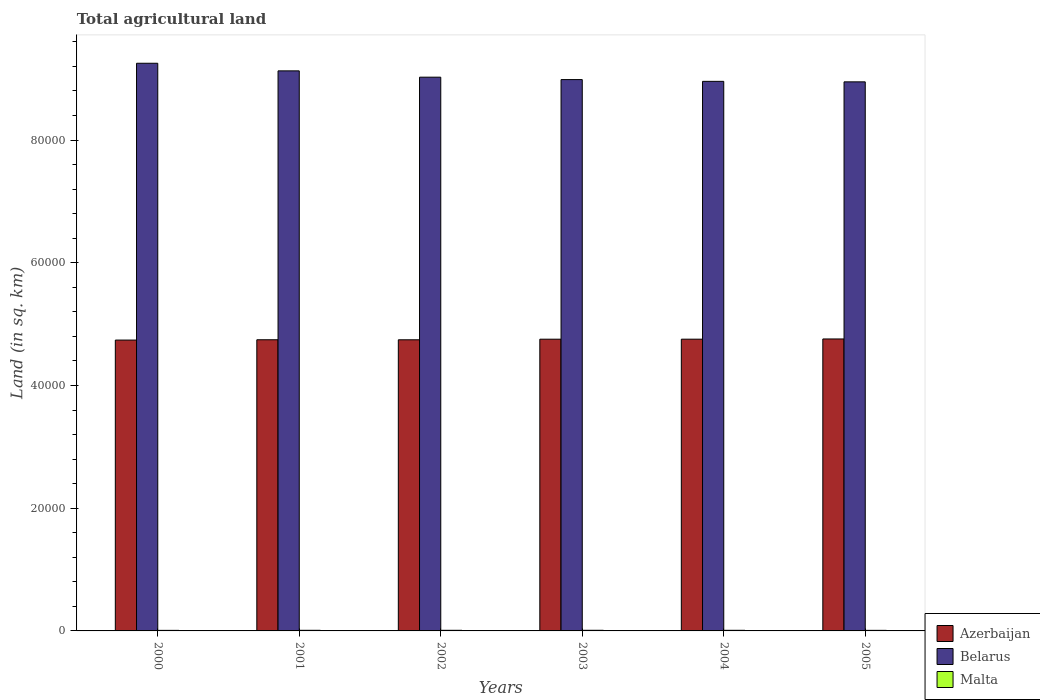Are the number of bars per tick equal to the number of legend labels?
Keep it short and to the point. Yes. Are the number of bars on each tick of the X-axis equal?
Your response must be concise. Yes. What is the total agricultural land in Malta in 2003?
Your response must be concise. 104. Across all years, what is the maximum total agricultural land in Belarus?
Offer a very short reply. 9.25e+04. Across all years, what is the minimum total agricultural land in Azerbaijan?
Provide a succinct answer. 4.74e+04. In which year was the total agricultural land in Malta maximum?
Provide a succinct answer. 2003. In which year was the total agricultural land in Belarus minimum?
Offer a terse response. 2005. What is the total total agricultural land in Malta in the graph?
Provide a succinct answer. 587. What is the difference between the total agricultural land in Azerbaijan in 2000 and the total agricultural land in Belarus in 2001?
Provide a succinct answer. -4.39e+04. What is the average total agricultural land in Belarus per year?
Provide a short and direct response. 9.05e+04. In the year 2001, what is the difference between the total agricultural land in Malta and total agricultural land in Belarus?
Offer a very short reply. -9.12e+04. In how many years, is the total agricultural land in Malta greater than 32000 sq.km?
Your answer should be very brief. 0. What is the ratio of the total agricultural land in Azerbaijan in 2001 to that in 2002?
Your answer should be compact. 1. Is the total agricultural land in Belarus in 2000 less than that in 2002?
Ensure brevity in your answer.  No. Is the difference between the total agricultural land in Malta in 2000 and 2005 greater than the difference between the total agricultural land in Belarus in 2000 and 2005?
Ensure brevity in your answer.  No. What is the difference between the highest and the second highest total agricultural land in Azerbaijan?
Make the answer very short. 37. In how many years, is the total agricultural land in Belarus greater than the average total agricultural land in Belarus taken over all years?
Ensure brevity in your answer.  2. What does the 3rd bar from the left in 2002 represents?
Make the answer very short. Malta. What does the 2nd bar from the right in 2003 represents?
Your answer should be very brief. Belarus. Is it the case that in every year, the sum of the total agricultural land in Malta and total agricultural land in Azerbaijan is greater than the total agricultural land in Belarus?
Provide a succinct answer. No. Are all the bars in the graph horizontal?
Offer a terse response. No. How many years are there in the graph?
Give a very brief answer. 6. What is the difference between two consecutive major ticks on the Y-axis?
Your answer should be compact. 2.00e+04. Are the values on the major ticks of Y-axis written in scientific E-notation?
Your answer should be compact. No. Does the graph contain any zero values?
Provide a short and direct response. No. Does the graph contain grids?
Make the answer very short. No. How many legend labels are there?
Keep it short and to the point. 3. What is the title of the graph?
Offer a terse response. Total agricultural land. What is the label or title of the X-axis?
Provide a succinct answer. Years. What is the label or title of the Y-axis?
Keep it short and to the point. Land (in sq. km). What is the Land (in sq. km) of Azerbaijan in 2000?
Provide a short and direct response. 4.74e+04. What is the Land (in sq. km) in Belarus in 2000?
Provide a succinct answer. 9.25e+04. What is the Land (in sq. km) in Malta in 2000?
Keep it short and to the point. 90. What is the Land (in sq. km) of Azerbaijan in 2001?
Your response must be concise. 4.75e+04. What is the Land (in sq. km) in Belarus in 2001?
Provide a succinct answer. 9.13e+04. What is the Land (in sq. km) in Malta in 2001?
Give a very brief answer. 100. What is the Land (in sq. km) of Azerbaijan in 2002?
Keep it short and to the point. 4.74e+04. What is the Land (in sq. km) of Belarus in 2002?
Offer a terse response. 9.02e+04. What is the Land (in sq. km) of Azerbaijan in 2003?
Make the answer very short. 4.75e+04. What is the Land (in sq. km) in Belarus in 2003?
Your answer should be very brief. 8.99e+04. What is the Land (in sq. km) of Malta in 2003?
Your response must be concise. 104. What is the Land (in sq. km) in Azerbaijan in 2004?
Make the answer very short. 4.75e+04. What is the Land (in sq. km) in Belarus in 2004?
Give a very brief answer. 8.96e+04. What is the Land (in sq. km) of Malta in 2004?
Your answer should be compact. 100. What is the Land (in sq. km) in Azerbaijan in 2005?
Keep it short and to the point. 4.76e+04. What is the Land (in sq. km) in Belarus in 2005?
Provide a short and direct response. 8.95e+04. What is the Land (in sq. km) of Malta in 2005?
Give a very brief answer. 93. Across all years, what is the maximum Land (in sq. km) of Azerbaijan?
Provide a short and direct response. 4.76e+04. Across all years, what is the maximum Land (in sq. km) of Belarus?
Offer a very short reply. 9.25e+04. Across all years, what is the maximum Land (in sq. km) in Malta?
Give a very brief answer. 104. Across all years, what is the minimum Land (in sq. km) of Azerbaijan?
Offer a very short reply. 4.74e+04. Across all years, what is the minimum Land (in sq. km) in Belarus?
Ensure brevity in your answer.  8.95e+04. Across all years, what is the minimum Land (in sq. km) in Malta?
Offer a terse response. 90. What is the total Land (in sq. km) of Azerbaijan in the graph?
Your answer should be very brief. 2.85e+05. What is the total Land (in sq. km) in Belarus in the graph?
Your answer should be compact. 5.43e+05. What is the total Land (in sq. km) of Malta in the graph?
Your answer should be compact. 587. What is the difference between the Land (in sq. km) in Azerbaijan in 2000 and that in 2001?
Your answer should be compact. -52. What is the difference between the Land (in sq. km) in Belarus in 2000 and that in 2001?
Provide a succinct answer. 1240. What is the difference between the Land (in sq. km) in Azerbaijan in 2000 and that in 2002?
Give a very brief answer. -45. What is the difference between the Land (in sq. km) of Belarus in 2000 and that in 2002?
Give a very brief answer. 2270. What is the difference between the Land (in sq. km) of Azerbaijan in 2000 and that in 2003?
Give a very brief answer. -142. What is the difference between the Land (in sq. km) of Belarus in 2000 and that in 2003?
Offer a very short reply. 2660. What is the difference between the Land (in sq. km) of Azerbaijan in 2000 and that in 2004?
Give a very brief answer. -145. What is the difference between the Land (in sq. km) of Belarus in 2000 and that in 2004?
Keep it short and to the point. 2950. What is the difference between the Land (in sq. km) of Malta in 2000 and that in 2004?
Offer a terse response. -10. What is the difference between the Land (in sq. km) in Azerbaijan in 2000 and that in 2005?
Keep it short and to the point. -182. What is the difference between the Land (in sq. km) in Belarus in 2000 and that in 2005?
Offer a very short reply. 3030. What is the difference between the Land (in sq. km) of Azerbaijan in 2001 and that in 2002?
Make the answer very short. 7. What is the difference between the Land (in sq. km) in Belarus in 2001 and that in 2002?
Your answer should be very brief. 1030. What is the difference between the Land (in sq. km) of Azerbaijan in 2001 and that in 2003?
Give a very brief answer. -90. What is the difference between the Land (in sq. km) in Belarus in 2001 and that in 2003?
Make the answer very short. 1420. What is the difference between the Land (in sq. km) of Azerbaijan in 2001 and that in 2004?
Ensure brevity in your answer.  -93. What is the difference between the Land (in sq. km) of Belarus in 2001 and that in 2004?
Keep it short and to the point. 1710. What is the difference between the Land (in sq. km) of Azerbaijan in 2001 and that in 2005?
Offer a very short reply. -130. What is the difference between the Land (in sq. km) in Belarus in 2001 and that in 2005?
Offer a very short reply. 1790. What is the difference between the Land (in sq. km) in Malta in 2001 and that in 2005?
Your answer should be compact. 7. What is the difference between the Land (in sq. km) in Azerbaijan in 2002 and that in 2003?
Make the answer very short. -97. What is the difference between the Land (in sq. km) of Belarus in 2002 and that in 2003?
Your answer should be very brief. 390. What is the difference between the Land (in sq. km) in Malta in 2002 and that in 2003?
Ensure brevity in your answer.  -4. What is the difference between the Land (in sq. km) of Azerbaijan in 2002 and that in 2004?
Give a very brief answer. -100. What is the difference between the Land (in sq. km) of Belarus in 2002 and that in 2004?
Provide a short and direct response. 680. What is the difference between the Land (in sq. km) of Azerbaijan in 2002 and that in 2005?
Your answer should be compact. -137. What is the difference between the Land (in sq. km) of Belarus in 2002 and that in 2005?
Keep it short and to the point. 760. What is the difference between the Land (in sq. km) in Azerbaijan in 2003 and that in 2004?
Ensure brevity in your answer.  -3. What is the difference between the Land (in sq. km) of Belarus in 2003 and that in 2004?
Your response must be concise. 290. What is the difference between the Land (in sq. km) of Belarus in 2003 and that in 2005?
Offer a very short reply. 370. What is the difference between the Land (in sq. km) in Malta in 2003 and that in 2005?
Offer a terse response. 11. What is the difference between the Land (in sq. km) of Azerbaijan in 2004 and that in 2005?
Your answer should be compact. -37. What is the difference between the Land (in sq. km) of Azerbaijan in 2000 and the Land (in sq. km) of Belarus in 2001?
Make the answer very short. -4.39e+04. What is the difference between the Land (in sq. km) of Azerbaijan in 2000 and the Land (in sq. km) of Malta in 2001?
Ensure brevity in your answer.  4.73e+04. What is the difference between the Land (in sq. km) of Belarus in 2000 and the Land (in sq. km) of Malta in 2001?
Your response must be concise. 9.24e+04. What is the difference between the Land (in sq. km) in Azerbaijan in 2000 and the Land (in sq. km) in Belarus in 2002?
Offer a very short reply. -4.28e+04. What is the difference between the Land (in sq. km) of Azerbaijan in 2000 and the Land (in sq. km) of Malta in 2002?
Keep it short and to the point. 4.73e+04. What is the difference between the Land (in sq. km) in Belarus in 2000 and the Land (in sq. km) in Malta in 2002?
Offer a terse response. 9.24e+04. What is the difference between the Land (in sq. km) of Azerbaijan in 2000 and the Land (in sq. km) of Belarus in 2003?
Provide a short and direct response. -4.25e+04. What is the difference between the Land (in sq. km) of Azerbaijan in 2000 and the Land (in sq. km) of Malta in 2003?
Your answer should be compact. 4.73e+04. What is the difference between the Land (in sq. km) of Belarus in 2000 and the Land (in sq. km) of Malta in 2003?
Provide a short and direct response. 9.24e+04. What is the difference between the Land (in sq. km) in Azerbaijan in 2000 and the Land (in sq. km) in Belarus in 2004?
Offer a very short reply. -4.22e+04. What is the difference between the Land (in sq. km) of Azerbaijan in 2000 and the Land (in sq. km) of Malta in 2004?
Your answer should be very brief. 4.73e+04. What is the difference between the Land (in sq. km) of Belarus in 2000 and the Land (in sq. km) of Malta in 2004?
Provide a short and direct response. 9.24e+04. What is the difference between the Land (in sq. km) in Azerbaijan in 2000 and the Land (in sq. km) in Belarus in 2005?
Provide a succinct answer. -4.21e+04. What is the difference between the Land (in sq. km) of Azerbaijan in 2000 and the Land (in sq. km) of Malta in 2005?
Provide a short and direct response. 4.73e+04. What is the difference between the Land (in sq. km) of Belarus in 2000 and the Land (in sq. km) of Malta in 2005?
Make the answer very short. 9.24e+04. What is the difference between the Land (in sq. km) of Azerbaijan in 2001 and the Land (in sq. km) of Belarus in 2002?
Offer a terse response. -4.28e+04. What is the difference between the Land (in sq. km) of Azerbaijan in 2001 and the Land (in sq. km) of Malta in 2002?
Ensure brevity in your answer.  4.74e+04. What is the difference between the Land (in sq. km) in Belarus in 2001 and the Land (in sq. km) in Malta in 2002?
Your answer should be compact. 9.12e+04. What is the difference between the Land (in sq. km) of Azerbaijan in 2001 and the Land (in sq. km) of Belarus in 2003?
Provide a succinct answer. -4.24e+04. What is the difference between the Land (in sq. km) of Azerbaijan in 2001 and the Land (in sq. km) of Malta in 2003?
Provide a short and direct response. 4.74e+04. What is the difference between the Land (in sq. km) in Belarus in 2001 and the Land (in sq. km) in Malta in 2003?
Offer a terse response. 9.12e+04. What is the difference between the Land (in sq. km) in Azerbaijan in 2001 and the Land (in sq. km) in Belarus in 2004?
Your answer should be compact. -4.21e+04. What is the difference between the Land (in sq. km) in Azerbaijan in 2001 and the Land (in sq. km) in Malta in 2004?
Keep it short and to the point. 4.74e+04. What is the difference between the Land (in sq. km) in Belarus in 2001 and the Land (in sq. km) in Malta in 2004?
Offer a terse response. 9.12e+04. What is the difference between the Land (in sq. km) of Azerbaijan in 2001 and the Land (in sq. km) of Belarus in 2005?
Provide a succinct answer. -4.20e+04. What is the difference between the Land (in sq. km) in Azerbaijan in 2001 and the Land (in sq. km) in Malta in 2005?
Your answer should be compact. 4.74e+04. What is the difference between the Land (in sq. km) in Belarus in 2001 and the Land (in sq. km) in Malta in 2005?
Your answer should be compact. 9.12e+04. What is the difference between the Land (in sq. km) of Azerbaijan in 2002 and the Land (in sq. km) of Belarus in 2003?
Your response must be concise. -4.24e+04. What is the difference between the Land (in sq. km) in Azerbaijan in 2002 and the Land (in sq. km) in Malta in 2003?
Keep it short and to the point. 4.73e+04. What is the difference between the Land (in sq. km) of Belarus in 2002 and the Land (in sq. km) of Malta in 2003?
Provide a short and direct response. 9.01e+04. What is the difference between the Land (in sq. km) in Azerbaijan in 2002 and the Land (in sq. km) in Belarus in 2004?
Give a very brief answer. -4.21e+04. What is the difference between the Land (in sq. km) in Azerbaijan in 2002 and the Land (in sq. km) in Malta in 2004?
Your answer should be compact. 4.73e+04. What is the difference between the Land (in sq. km) in Belarus in 2002 and the Land (in sq. km) in Malta in 2004?
Give a very brief answer. 9.02e+04. What is the difference between the Land (in sq. km) of Azerbaijan in 2002 and the Land (in sq. km) of Belarus in 2005?
Ensure brevity in your answer.  -4.20e+04. What is the difference between the Land (in sq. km) in Azerbaijan in 2002 and the Land (in sq. km) in Malta in 2005?
Offer a terse response. 4.74e+04. What is the difference between the Land (in sq. km) of Belarus in 2002 and the Land (in sq. km) of Malta in 2005?
Provide a short and direct response. 9.02e+04. What is the difference between the Land (in sq. km) of Azerbaijan in 2003 and the Land (in sq. km) of Belarus in 2004?
Provide a short and direct response. -4.20e+04. What is the difference between the Land (in sq. km) of Azerbaijan in 2003 and the Land (in sq. km) of Malta in 2004?
Provide a succinct answer. 4.74e+04. What is the difference between the Land (in sq. km) in Belarus in 2003 and the Land (in sq. km) in Malta in 2004?
Your answer should be very brief. 8.98e+04. What is the difference between the Land (in sq. km) in Azerbaijan in 2003 and the Land (in sq. km) in Belarus in 2005?
Keep it short and to the point. -4.19e+04. What is the difference between the Land (in sq. km) of Azerbaijan in 2003 and the Land (in sq. km) of Malta in 2005?
Your answer should be very brief. 4.75e+04. What is the difference between the Land (in sq. km) of Belarus in 2003 and the Land (in sq. km) of Malta in 2005?
Offer a terse response. 8.98e+04. What is the difference between the Land (in sq. km) in Azerbaijan in 2004 and the Land (in sq. km) in Belarus in 2005?
Offer a terse response. -4.19e+04. What is the difference between the Land (in sq. km) in Azerbaijan in 2004 and the Land (in sq. km) in Malta in 2005?
Offer a very short reply. 4.75e+04. What is the difference between the Land (in sq. km) in Belarus in 2004 and the Land (in sq. km) in Malta in 2005?
Provide a short and direct response. 8.95e+04. What is the average Land (in sq. km) of Azerbaijan per year?
Your answer should be compact. 4.75e+04. What is the average Land (in sq. km) in Belarus per year?
Your answer should be compact. 9.05e+04. What is the average Land (in sq. km) in Malta per year?
Give a very brief answer. 97.83. In the year 2000, what is the difference between the Land (in sq. km) of Azerbaijan and Land (in sq. km) of Belarus?
Give a very brief answer. -4.51e+04. In the year 2000, what is the difference between the Land (in sq. km) in Azerbaijan and Land (in sq. km) in Malta?
Keep it short and to the point. 4.73e+04. In the year 2000, what is the difference between the Land (in sq. km) in Belarus and Land (in sq. km) in Malta?
Your answer should be compact. 9.24e+04. In the year 2001, what is the difference between the Land (in sq. km) of Azerbaijan and Land (in sq. km) of Belarus?
Give a very brief answer. -4.38e+04. In the year 2001, what is the difference between the Land (in sq. km) of Azerbaijan and Land (in sq. km) of Malta?
Your response must be concise. 4.74e+04. In the year 2001, what is the difference between the Land (in sq. km) in Belarus and Land (in sq. km) in Malta?
Make the answer very short. 9.12e+04. In the year 2002, what is the difference between the Land (in sq. km) of Azerbaijan and Land (in sq. km) of Belarus?
Provide a succinct answer. -4.28e+04. In the year 2002, what is the difference between the Land (in sq. km) of Azerbaijan and Land (in sq. km) of Malta?
Ensure brevity in your answer.  4.73e+04. In the year 2002, what is the difference between the Land (in sq. km) in Belarus and Land (in sq. km) in Malta?
Provide a short and direct response. 9.02e+04. In the year 2003, what is the difference between the Land (in sq. km) in Azerbaijan and Land (in sq. km) in Belarus?
Make the answer very short. -4.23e+04. In the year 2003, what is the difference between the Land (in sq. km) of Azerbaijan and Land (in sq. km) of Malta?
Make the answer very short. 4.74e+04. In the year 2003, what is the difference between the Land (in sq. km) of Belarus and Land (in sq. km) of Malta?
Your response must be concise. 8.98e+04. In the year 2004, what is the difference between the Land (in sq. km) in Azerbaijan and Land (in sq. km) in Belarus?
Offer a terse response. -4.20e+04. In the year 2004, what is the difference between the Land (in sq. km) in Azerbaijan and Land (in sq. km) in Malta?
Provide a succinct answer. 4.74e+04. In the year 2004, what is the difference between the Land (in sq. km) of Belarus and Land (in sq. km) of Malta?
Give a very brief answer. 8.95e+04. In the year 2005, what is the difference between the Land (in sq. km) of Azerbaijan and Land (in sq. km) of Belarus?
Provide a succinct answer. -4.19e+04. In the year 2005, what is the difference between the Land (in sq. km) in Azerbaijan and Land (in sq. km) in Malta?
Make the answer very short. 4.75e+04. In the year 2005, what is the difference between the Land (in sq. km) in Belarus and Land (in sq. km) in Malta?
Your response must be concise. 8.94e+04. What is the ratio of the Land (in sq. km) in Belarus in 2000 to that in 2001?
Ensure brevity in your answer.  1.01. What is the ratio of the Land (in sq. km) in Malta in 2000 to that in 2001?
Give a very brief answer. 0.9. What is the ratio of the Land (in sq. km) in Azerbaijan in 2000 to that in 2002?
Ensure brevity in your answer.  1. What is the ratio of the Land (in sq. km) in Belarus in 2000 to that in 2002?
Your response must be concise. 1.03. What is the ratio of the Land (in sq. km) of Malta in 2000 to that in 2002?
Your answer should be very brief. 0.9. What is the ratio of the Land (in sq. km) of Belarus in 2000 to that in 2003?
Provide a short and direct response. 1.03. What is the ratio of the Land (in sq. km) of Malta in 2000 to that in 2003?
Your answer should be very brief. 0.87. What is the ratio of the Land (in sq. km) in Azerbaijan in 2000 to that in 2004?
Your answer should be compact. 1. What is the ratio of the Land (in sq. km) of Belarus in 2000 to that in 2004?
Your response must be concise. 1.03. What is the ratio of the Land (in sq. km) in Belarus in 2000 to that in 2005?
Offer a terse response. 1.03. What is the ratio of the Land (in sq. km) of Malta in 2000 to that in 2005?
Give a very brief answer. 0.97. What is the ratio of the Land (in sq. km) of Azerbaijan in 2001 to that in 2002?
Ensure brevity in your answer.  1. What is the ratio of the Land (in sq. km) of Belarus in 2001 to that in 2002?
Keep it short and to the point. 1.01. What is the ratio of the Land (in sq. km) of Malta in 2001 to that in 2002?
Ensure brevity in your answer.  1. What is the ratio of the Land (in sq. km) of Azerbaijan in 2001 to that in 2003?
Offer a terse response. 1. What is the ratio of the Land (in sq. km) of Belarus in 2001 to that in 2003?
Provide a short and direct response. 1.02. What is the ratio of the Land (in sq. km) in Malta in 2001 to that in 2003?
Your response must be concise. 0.96. What is the ratio of the Land (in sq. km) in Belarus in 2001 to that in 2004?
Offer a terse response. 1.02. What is the ratio of the Land (in sq. km) of Malta in 2001 to that in 2004?
Ensure brevity in your answer.  1. What is the ratio of the Land (in sq. km) in Azerbaijan in 2001 to that in 2005?
Your answer should be very brief. 1. What is the ratio of the Land (in sq. km) of Belarus in 2001 to that in 2005?
Provide a succinct answer. 1.02. What is the ratio of the Land (in sq. km) in Malta in 2001 to that in 2005?
Provide a succinct answer. 1.08. What is the ratio of the Land (in sq. km) in Malta in 2002 to that in 2003?
Ensure brevity in your answer.  0.96. What is the ratio of the Land (in sq. km) in Belarus in 2002 to that in 2004?
Make the answer very short. 1.01. What is the ratio of the Land (in sq. km) in Azerbaijan in 2002 to that in 2005?
Make the answer very short. 1. What is the ratio of the Land (in sq. km) in Belarus in 2002 to that in 2005?
Your answer should be compact. 1.01. What is the ratio of the Land (in sq. km) in Malta in 2002 to that in 2005?
Give a very brief answer. 1.08. What is the ratio of the Land (in sq. km) in Azerbaijan in 2003 to that in 2005?
Offer a very short reply. 1. What is the ratio of the Land (in sq. km) of Belarus in 2003 to that in 2005?
Your response must be concise. 1. What is the ratio of the Land (in sq. km) in Malta in 2003 to that in 2005?
Provide a succinct answer. 1.12. What is the ratio of the Land (in sq. km) of Malta in 2004 to that in 2005?
Ensure brevity in your answer.  1.08. What is the difference between the highest and the second highest Land (in sq. km) of Belarus?
Offer a very short reply. 1240. What is the difference between the highest and the lowest Land (in sq. km) of Azerbaijan?
Offer a terse response. 182. What is the difference between the highest and the lowest Land (in sq. km) in Belarus?
Offer a terse response. 3030. 